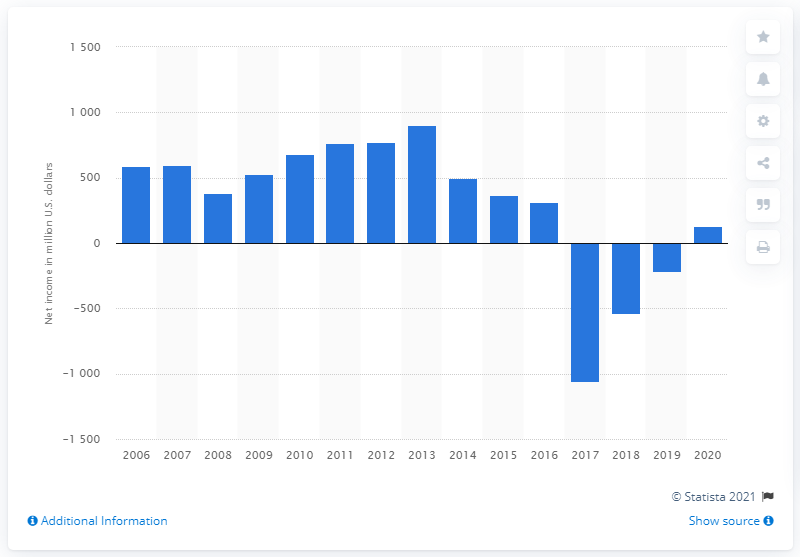Indicate a few pertinent items in this graphic. Mattel's net income in 2020 was $126.6 million in dollars. 